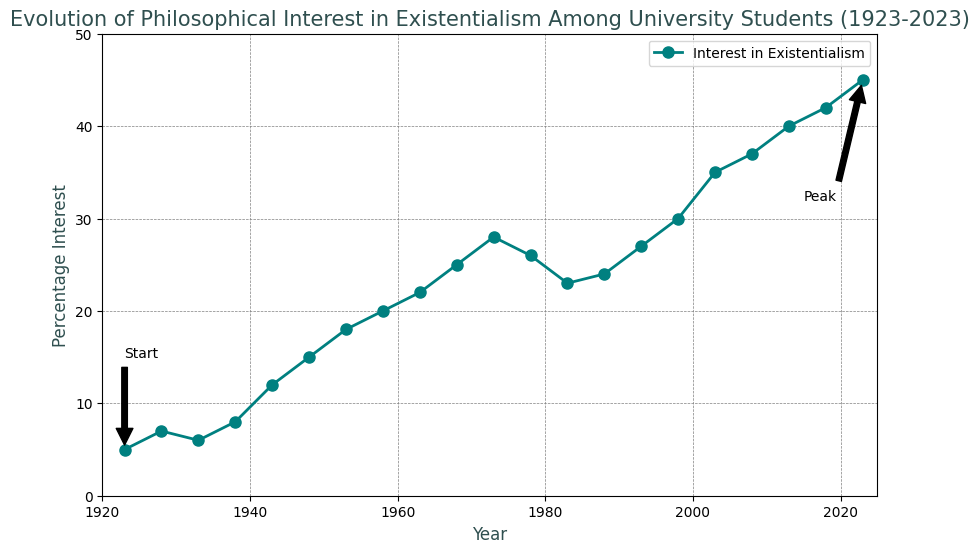What year marks the peak interest in existentialism? The peak interest is denoted by the highest percentage interest and it is annotated in the figure. Looking at the annotation "Peak", it indicates that 2023 is the year with the highest interest.
Answer: 2023 Compare the interest percentage between the years 1943 and 1998. Which year had a higher interest and by how much? The percentage interest in 1943 is 12% and in 1998 it is 30%. Subtracting these values, 1998 had an 18% higher interest than 1943.
Answer: 1998, by 18% What is the trend in the interest in existentialism from 1938 to 1948? From 1938 to 1948, the percentage increased from 8% to 15%. Therefore, the trend is an upward trend.
Answer: Upward What is the average percentage interest from 2003 to 2023? The values from 2003 to 2023 are 35, 37, 40, 42, and 45. Summing them up gives 199. Dividing by the number of values, 199/5 = 39.8.
Answer: 39.8 Between which consecutive 5-year periods did the interest percentage drop the most? We need to compare the interest percentage between each set of consecutive 5-year periods. From 1973 to 1978, the interest dropped from 28% to 26%, a drop of 2%, which is the highest drop among the periods observed.
Answer: 1973-1978 What percentage interest was observed exactly midway through the century in 1973? Looking at the data, the interest percentage in 1973 was 28%.
Answer: 28% How much did the interest percentage increase from the start to the end of the observation period? The interest at the start in 1923 is 5%, and at the end in 2023 is 45%. The increase is 45% - 5% = 40%.
Answer: 40% Identify a period where the interest percentage remained stable or only slightly changed. Observing the trend from 1983 to 1988, the interest percentage remained relatively stable, from 23% to 24%.
Answer: 1983-1988 